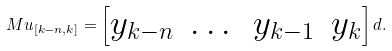Convert formula to latex. <formula><loc_0><loc_0><loc_500><loc_500>M u _ { [ k - n , k ] } = \begin{bmatrix} y _ { k - n } & \dots & y _ { k - 1 } & y _ { k } \end{bmatrix} d .</formula> 